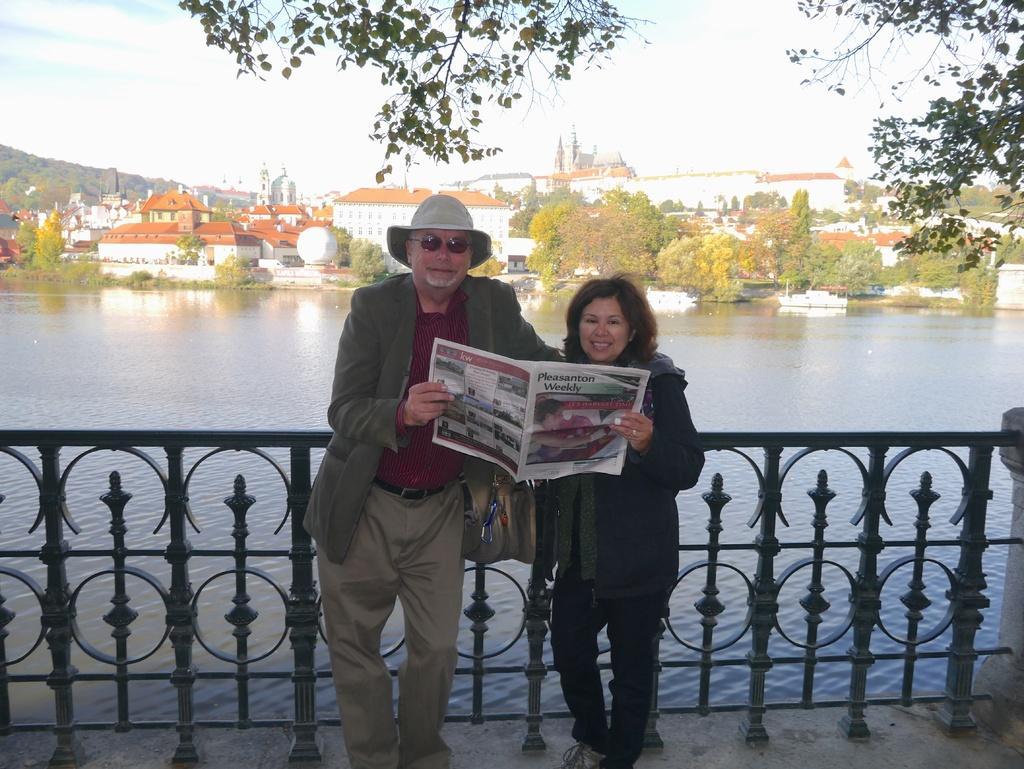Please provide a concise description of this image. In this image I can see two persons, a newspaper, iron fencing, water, boats, buildings, trees, and in the background there is sky. 